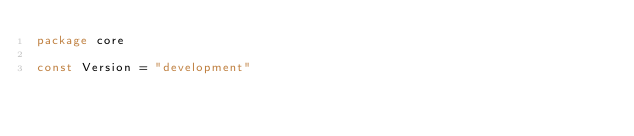Convert code to text. <code><loc_0><loc_0><loc_500><loc_500><_Go_>package core

const Version = "development"
</code> 